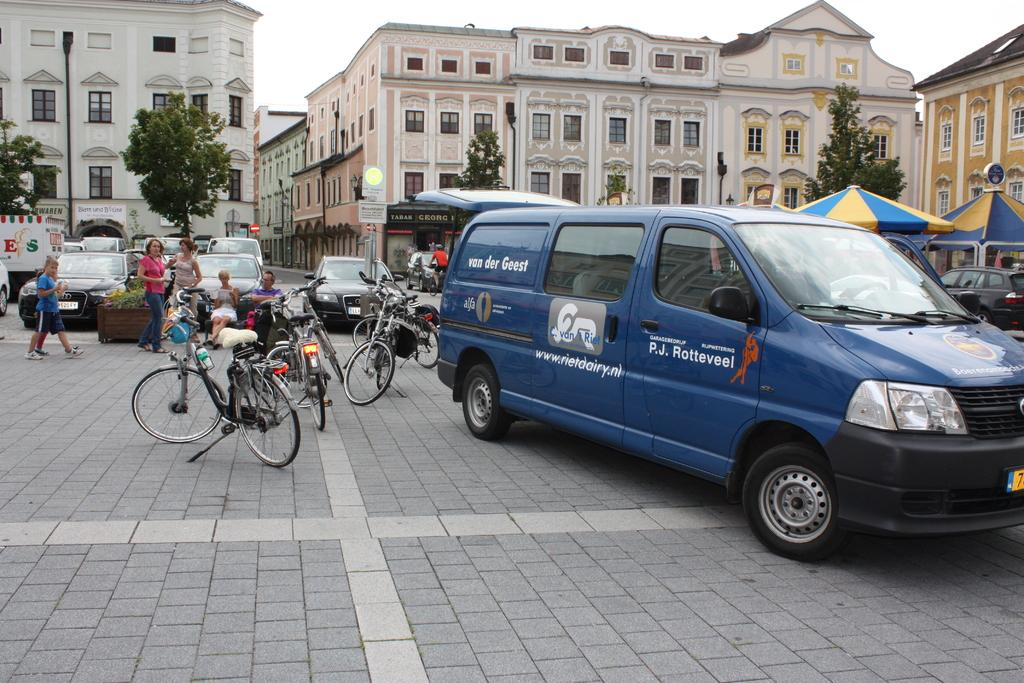<image>
Describe the image concisely. A commercial blue van that has P.J. Rotteveel advertising on the side. 